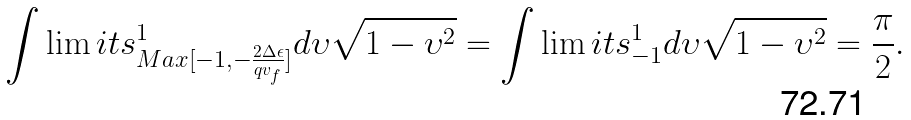<formula> <loc_0><loc_0><loc_500><loc_500>\int \lim i t s _ { M a x [ - 1 , - \frac { 2 \Delta \epsilon } { q v _ { f } } ] } ^ { 1 } d \upsilon \sqrt { 1 - \upsilon ^ { 2 } } = \int \lim i t s _ { - 1 } ^ { 1 } d \upsilon \sqrt { 1 - \upsilon ^ { 2 } } = \frac { \pi } { 2 } .</formula> 